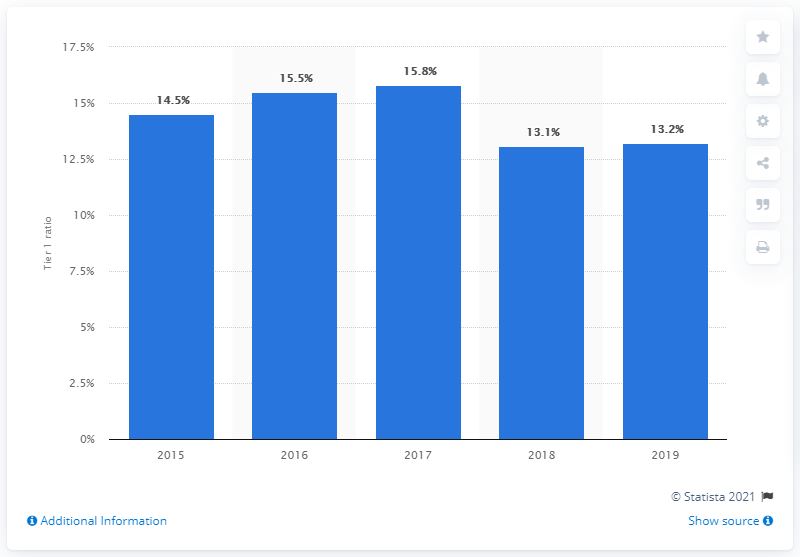How does the 2019 Tier 1 ratio of Crédit Agricole compare to the previous years? In 2019, the Tier 1 ratio of Crédit Agricole was at 13.2%, which is the lowest compared to the preceding four years. The bar chart shows a decline from the highest ratio of 15.8% in 2017. 